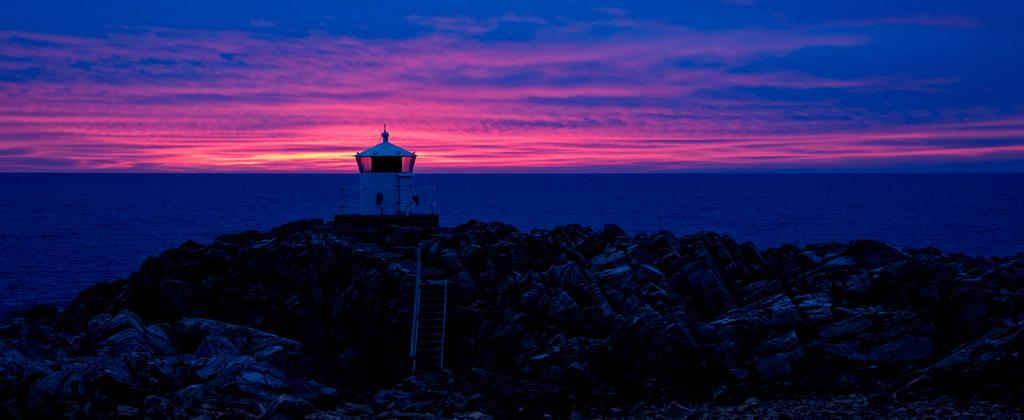What time of day is depicted in the image? The image depicts a sunset. What natural feature is visible in the image? There is a sea in the image. What structure can be seen near the sea? There is a lighthouse on rocks in the image. How many beads are present in the image? There are no beads present in the image. Is anyone wearing a ring in the image? There are no people visible in the image, so it is impossible to determine if anyone is wearing a ring. 